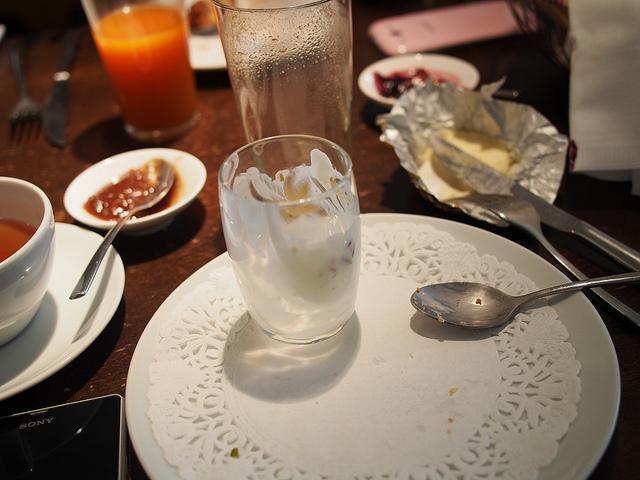How many cell phones are on the table?
Give a very brief answer. 2. How many glasses are in this picture?
Give a very brief answer. 3. How many spoons are on the table?
Give a very brief answer. 2. How many wine glasses are there?
Give a very brief answer. 0. How many cell phones can you see?
Give a very brief answer. 2. How many cups can you see?
Give a very brief answer. 3. How many knives are there?
Give a very brief answer. 1. How many bowls are there?
Give a very brief answer. 3. How many chairs don't have a dog on them?
Give a very brief answer. 0. 